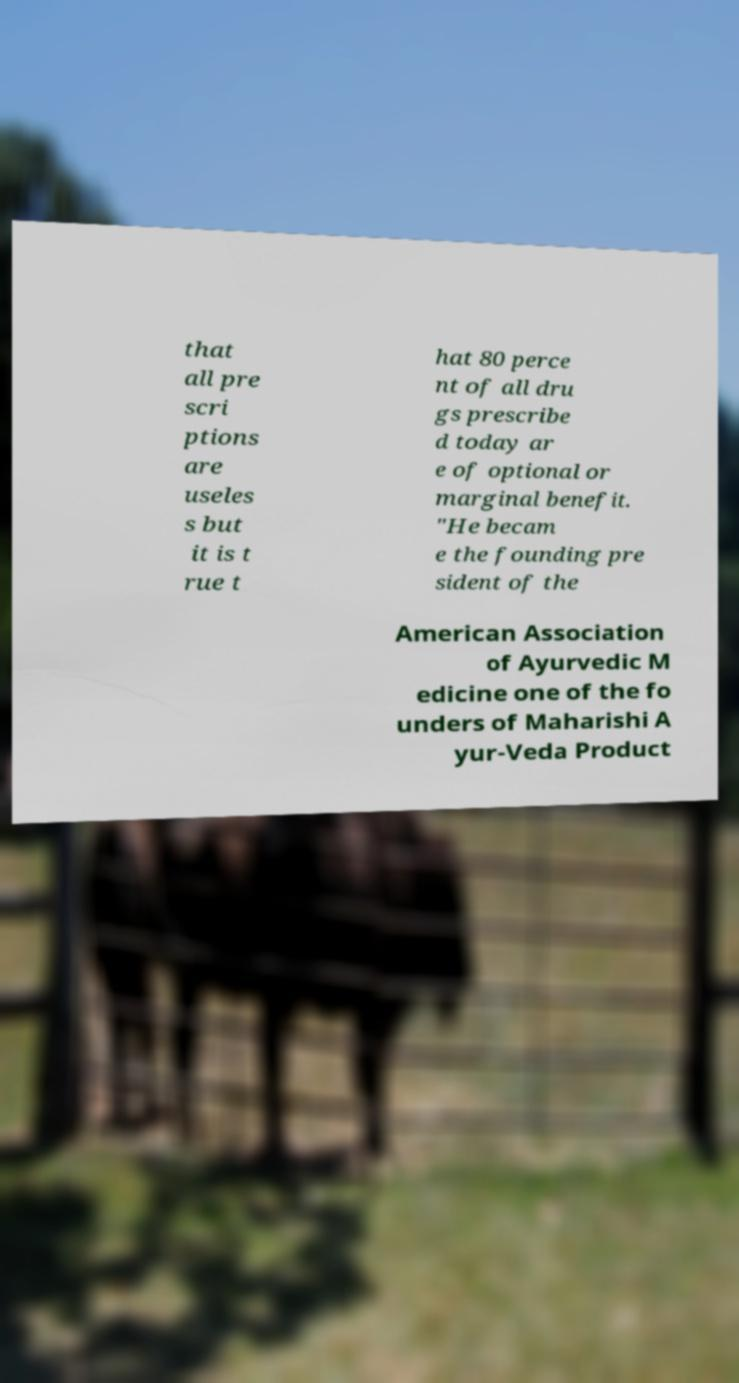Could you extract and type out the text from this image? that all pre scri ptions are useles s but it is t rue t hat 80 perce nt of all dru gs prescribe d today ar e of optional or marginal benefit. "He becam e the founding pre sident of the American Association of Ayurvedic M edicine one of the fo unders of Maharishi A yur-Veda Product 